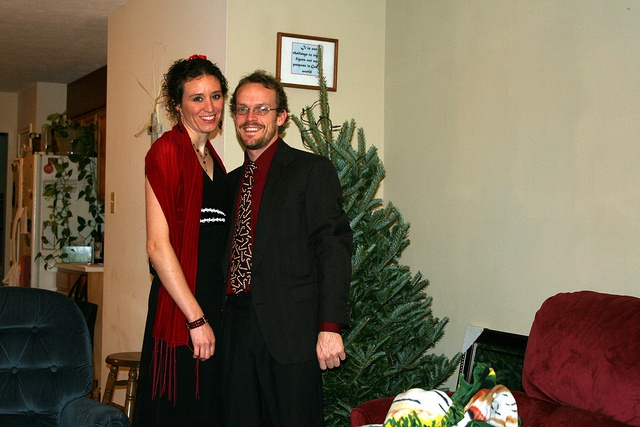Describe the objects in this image and their specific colors. I can see people in gray, black, maroon, brown, and salmon tones, people in gray, black, maroon, salmon, and brown tones, couch in gray, maroon, black, white, and darkgreen tones, chair in gray, black, darkblue, and purple tones, and refrigerator in gray, black, and maroon tones in this image. 